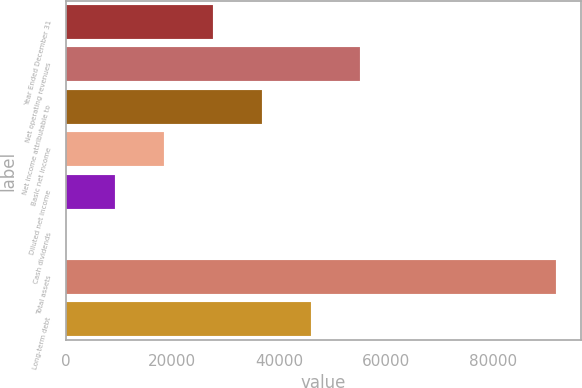Convert chart to OTSL. <chart><loc_0><loc_0><loc_500><loc_500><bar_chart><fcel>Year Ended December 31<fcel>Net operating revenues<fcel>Net income attributable to<fcel>Basic net income<fcel>Diluted net income<fcel>Cash dividends<fcel>Total assets<fcel>Long-term debt<nl><fcel>27591.3<fcel>55181.3<fcel>36787.9<fcel>18394.6<fcel>9197.9<fcel>1.22<fcel>91968<fcel>45984.6<nl></chart> 